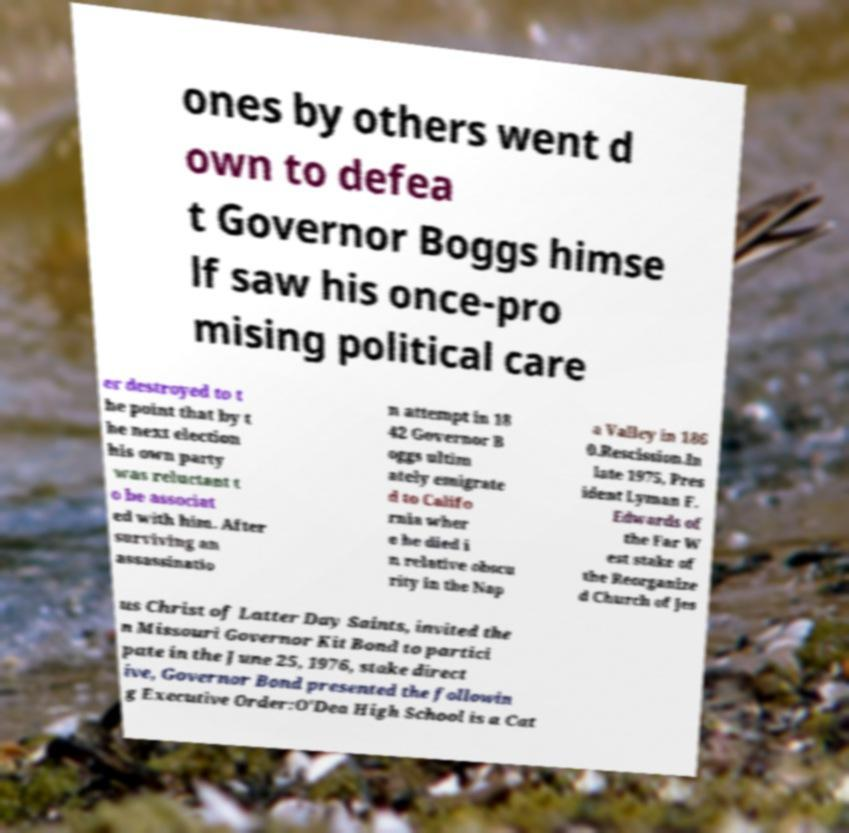There's text embedded in this image that I need extracted. Can you transcribe it verbatim? ones by others went d own to defea t Governor Boggs himse lf saw his once-pro mising political care er destroyed to t he point that by t he next election his own party was reluctant t o be associat ed with him. After surviving an assassinatio n attempt in 18 42 Governor B oggs ultim ately emigrate d to Califo rnia wher e he died i n relative obscu rity in the Nap a Valley in 186 0.Rescission.In late 1975, Pres ident Lyman F. Edwards of the Far W est stake of the Reorganize d Church of Jes us Christ of Latter Day Saints, invited the n Missouri Governor Kit Bond to partici pate in the June 25, 1976, stake direct ive, Governor Bond presented the followin g Executive Order:O'Dea High School is a Cat 